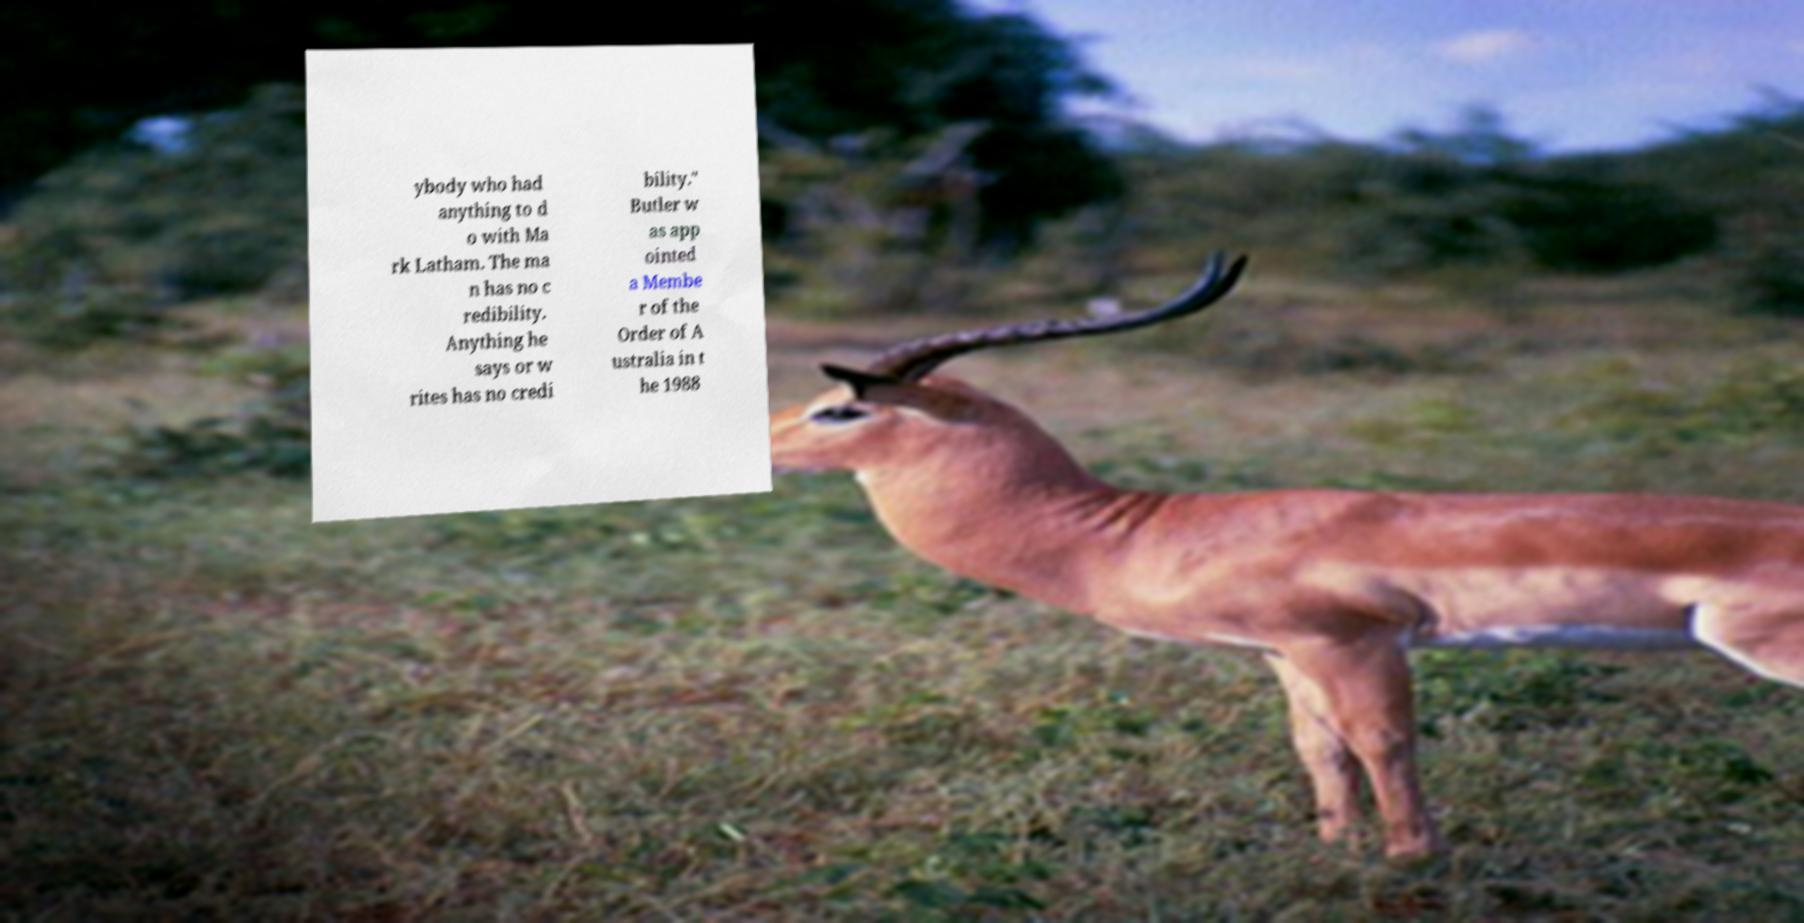I need the written content from this picture converted into text. Can you do that? ybody who had anything to d o with Ma rk Latham. The ma n has no c redibility. Anything he says or w rites has no credi bility." Butler w as app ointed a Membe r of the Order of A ustralia in t he 1988 